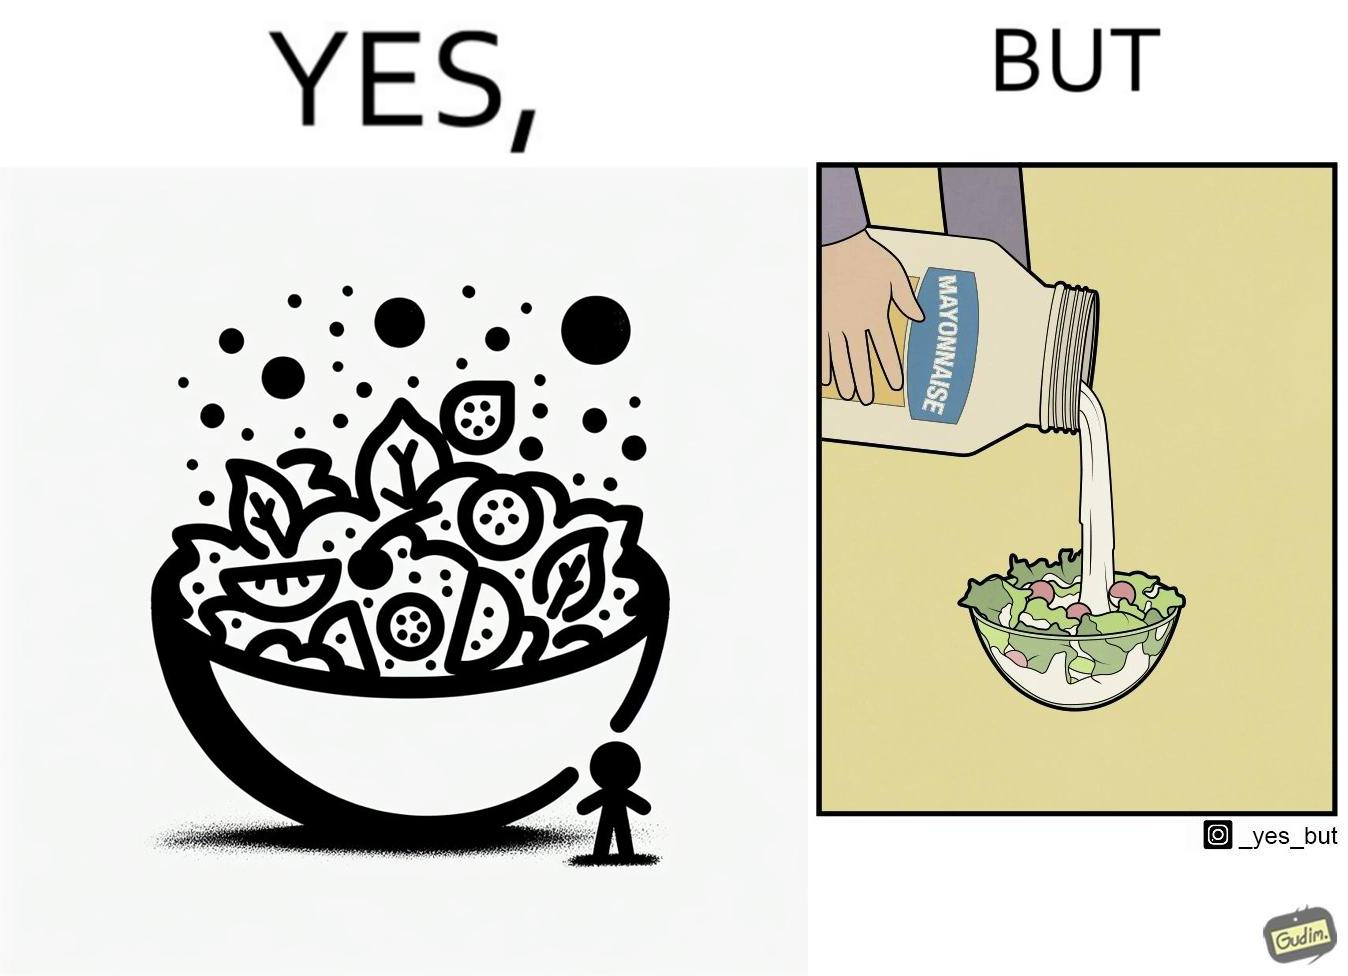What does this image depict? The image is ironical, as salad in a bowl by itself is very healthy. However, when people have it with Mayonnaise sauce to improve the taste, it is not healthy anymore, and defeats the point of having nutrient-rich salad altogether. 